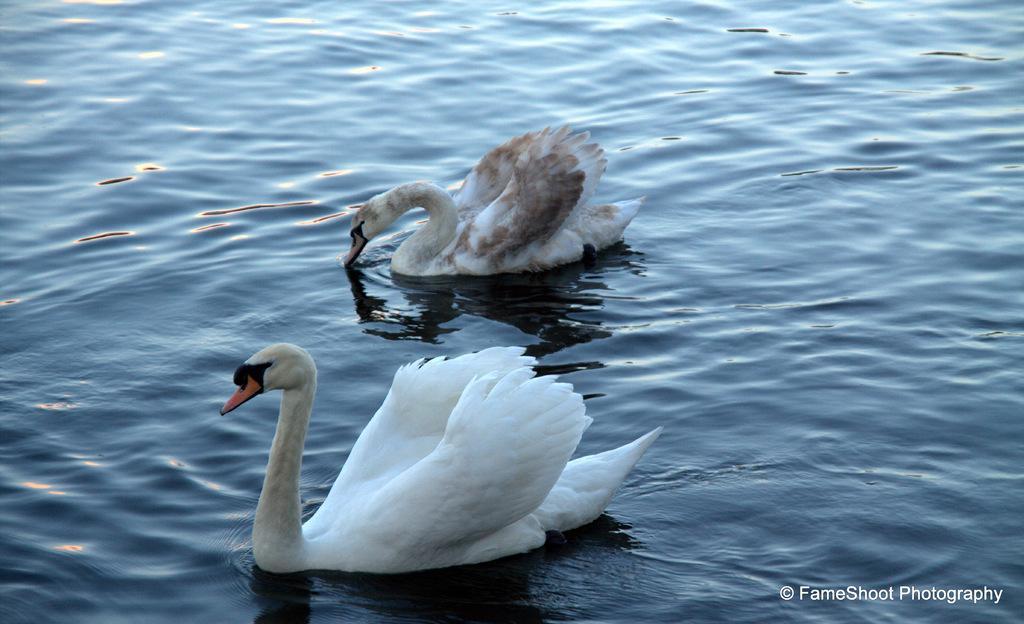Can you describe this image briefly? In the image there are two swans swimming in the water. 